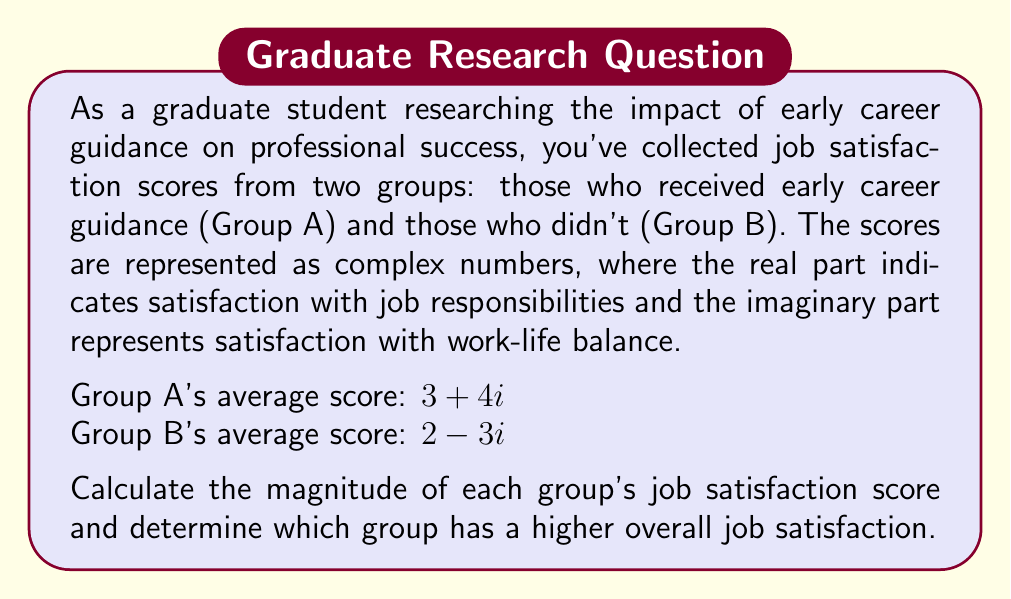Could you help me with this problem? To solve this problem, we need to calculate the magnitude of each complex number representing the job satisfaction scores. The magnitude of a complex number $z = a + bi$ is given by the formula:

$$|z| = \sqrt{a^2 + b^2}$$

For Group A:
$z_A = 3 + 4i$
$|z_A| = \sqrt{3^2 + 4^2}$
$|z_A| = \sqrt{9 + 16}$
$|z_A| = \sqrt{25}$
$|z_A| = 5$

For Group B:
$z_B = 2 - 3i$
$|z_B| = \sqrt{2^2 + (-3)^2}$
$|z_B| = \sqrt{4 + 9}$
$|z_B| = \sqrt{13}$
$|z_B| \approx 3.61$

Comparing the magnitudes:
$|z_A| = 5 > |z_B| \approx 3.61$

Therefore, Group A, which received early career guidance, has a higher overall job satisfaction score.
Answer: Group A magnitude: 5
Group B magnitude: $\sqrt{13} \approx 3.61$
Group A has a higher overall job satisfaction. 